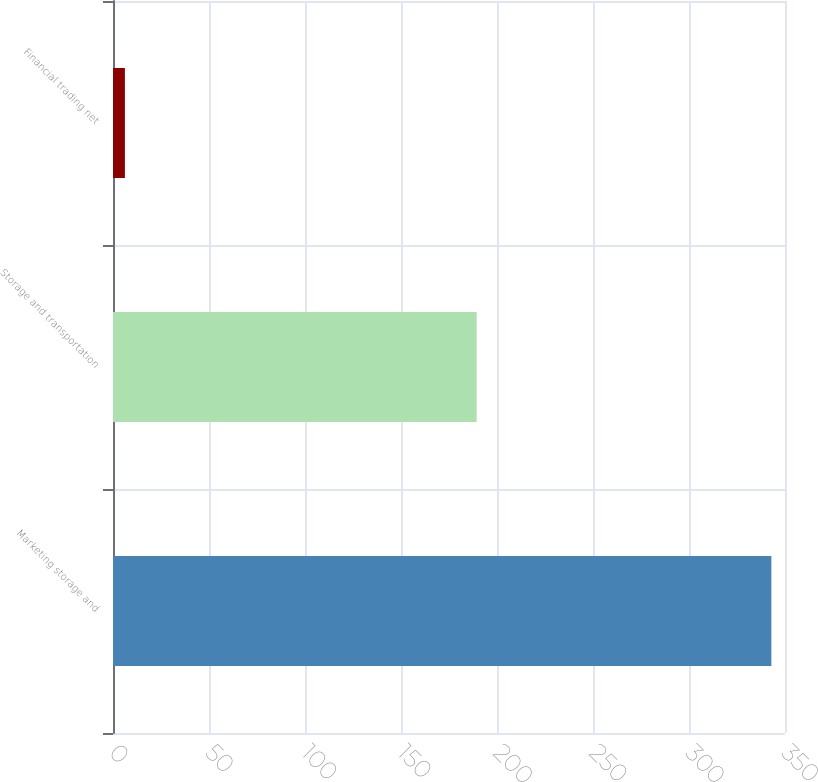Convert chart to OTSL. <chart><loc_0><loc_0><loc_500><loc_500><bar_chart><fcel>Marketing storage and<fcel>Storage and transportation<fcel>Financial trading net<nl><fcel>342.9<fcel>189.4<fcel>6.2<nl></chart> 